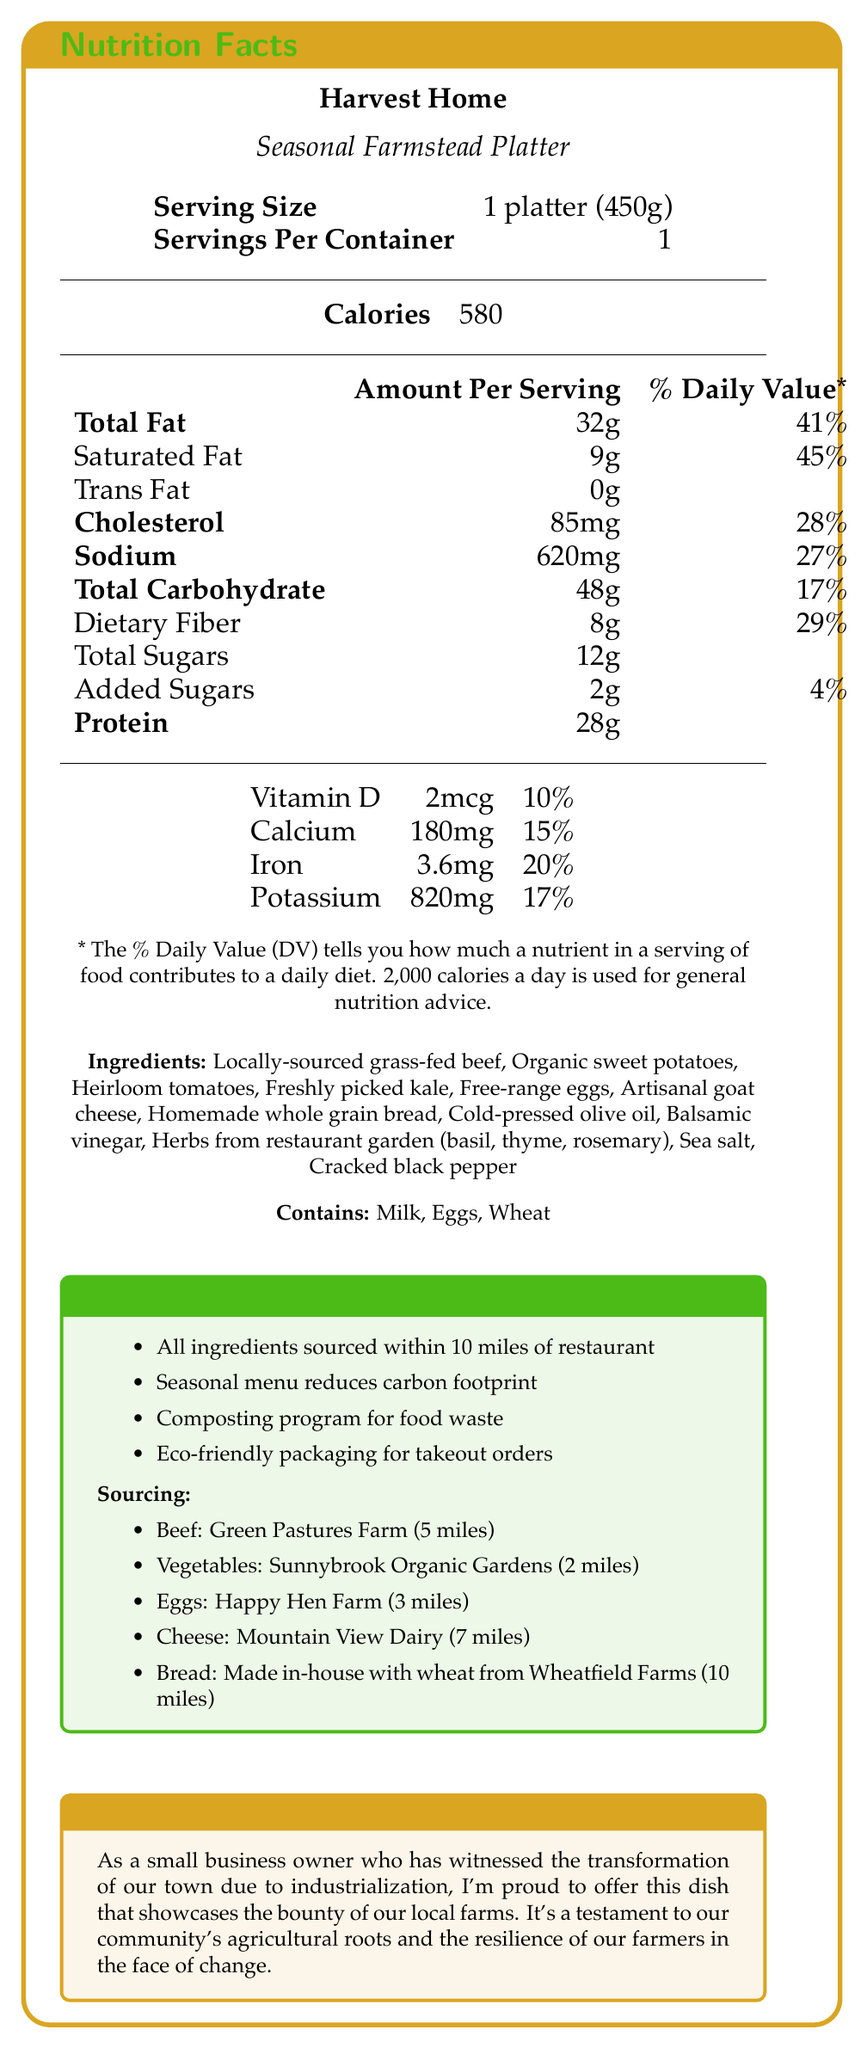What is the serving size for the Seasonal Farmstead Platter? The serving size is specified as "1 platter (450g)" in the document.
Answer: 1 platter (450g) How many calories are in one serving of the Seasonal Farmstead Platter? The document lists the number of calories per serving as 580.
Answer: 580 calories What is the percentage daily value of saturated fat in the Seasonal Farmstead Platter? According to the document, the saturated fat content is 9g, which is 45% of the daily value.
Answer: 45% How much dietary fiber is in the Seasonal Farmstead Platter? The document indicates that the dish contains 8g of dietary fiber.
Answer: 8g List three of the seasonal ingredients used in the Seasonal Farmstead Platter. The ingredients section lists all the components of the dish, including these three.
Answer: Organic sweet potatoes, Heirloom tomatoes, Freshly picked kale What allergens are present in the Seasonal Farmstead Platter? A. Milk B. Eggs C. Wheat D. All of the above The document specifies that the dish contains milk, eggs, and wheat.
Answer: D. All of the above What is the primary source of protein in the Seasonal Farmstead Platter? The ingredients section lists "Locally-sourced grass-fed beef" as one of the primary ingredients.
Answer: Locally-sourced grass-fed beef How many miles away is Green Pastures Farm, the source of the beef? A. 2 miles B. 3 miles C. 5 miles D. 7 miles The sourcing information indicates that Green Pastures Farm is 5 miles away.
Answer: C. 5 miles Does the Seasonal Farmstead Platter contain trans fat? The document states that the dish contains 0g of trans fat.
Answer: No Describe the main idea of the document. The document details the nutritional and sourcing information for the Seasonal Farmstead Platter, emphasizing its use of local, fresh, and seasonal ingredients reflective of the community’s agricultural roots.
Answer: The document provides a detailed Nutrition Facts Label for Harvest Home's signature dish, the Seasonal Farmstead Platter. It includes nutritional information, ingredients, allergen information, sourcing details, sustainability notes, and a chef's note highlighting the local and seasonal nature of the ingredients. How many servings are in one container of the Seasonal Farmstead Platter? The document specifies that there is 1 serving per container.
Answer: 1 What is the percentage daily value of sodium in the dish? The sodium content is listed as 620mg, which corresponds to 27% of the daily value.
Answer: 27% Is there Vitamin C listed in the nutritional information? The document does not mention Vitamin C in the nutritional information.
Answer: No How does the Seasonal Farmstead Platter contribute to sustainability? The sustainability notes section lists several points about how the dish and restaurant contribute to sustainability.
Answer: It includes ingredients sourced within 10 miles, has a seasonal menu, supports a composting program, and uses eco-friendly packaging. 